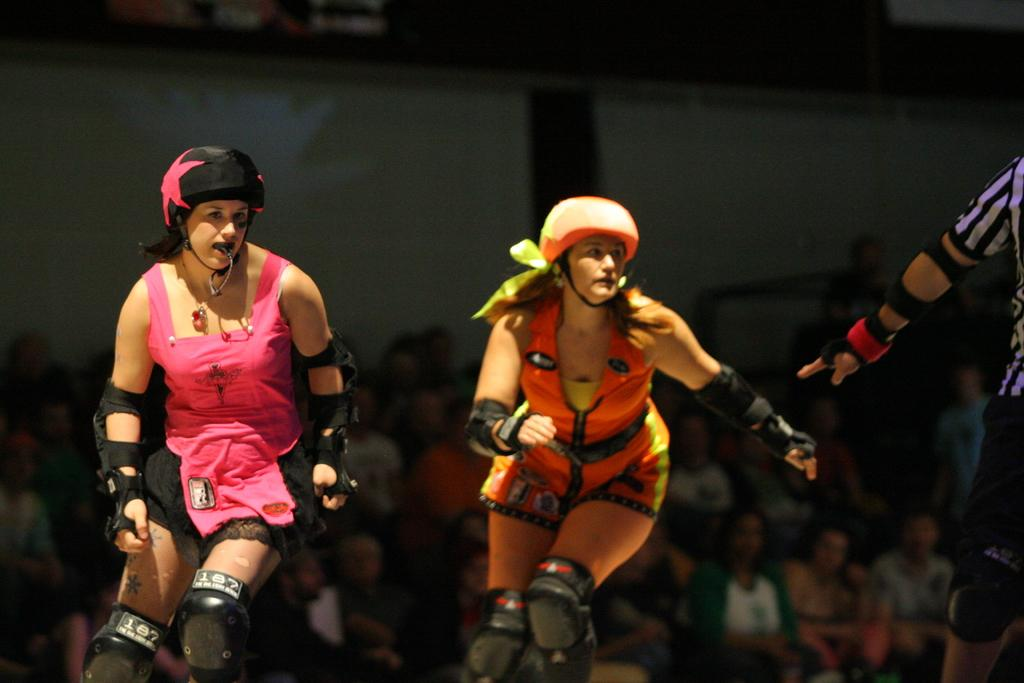How many people are in the image? A: There are persons in the image, but the exact number is not specified. What can be seen in the background of the image? The background of the image includes persons, a wall, and other objects. Can you describe the position of a person in the image? Yes, there appears to be a person on the right side of the image. What type of oil is being used to measure the toad in the image? There is no oil, measurement, or toad present in the image. 